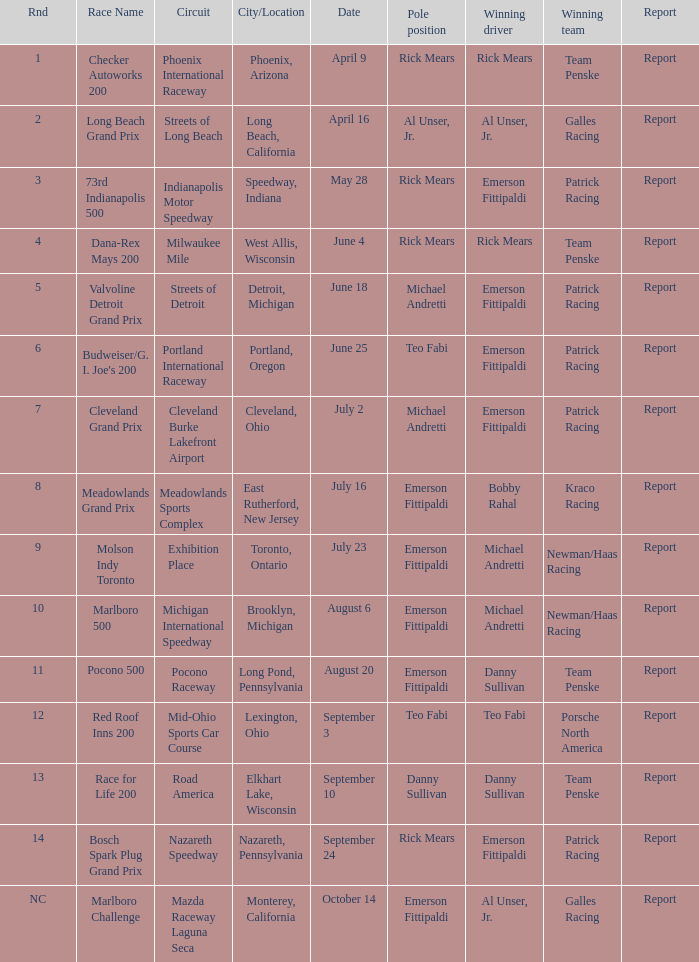What report was there for the porsche north america? Report. 